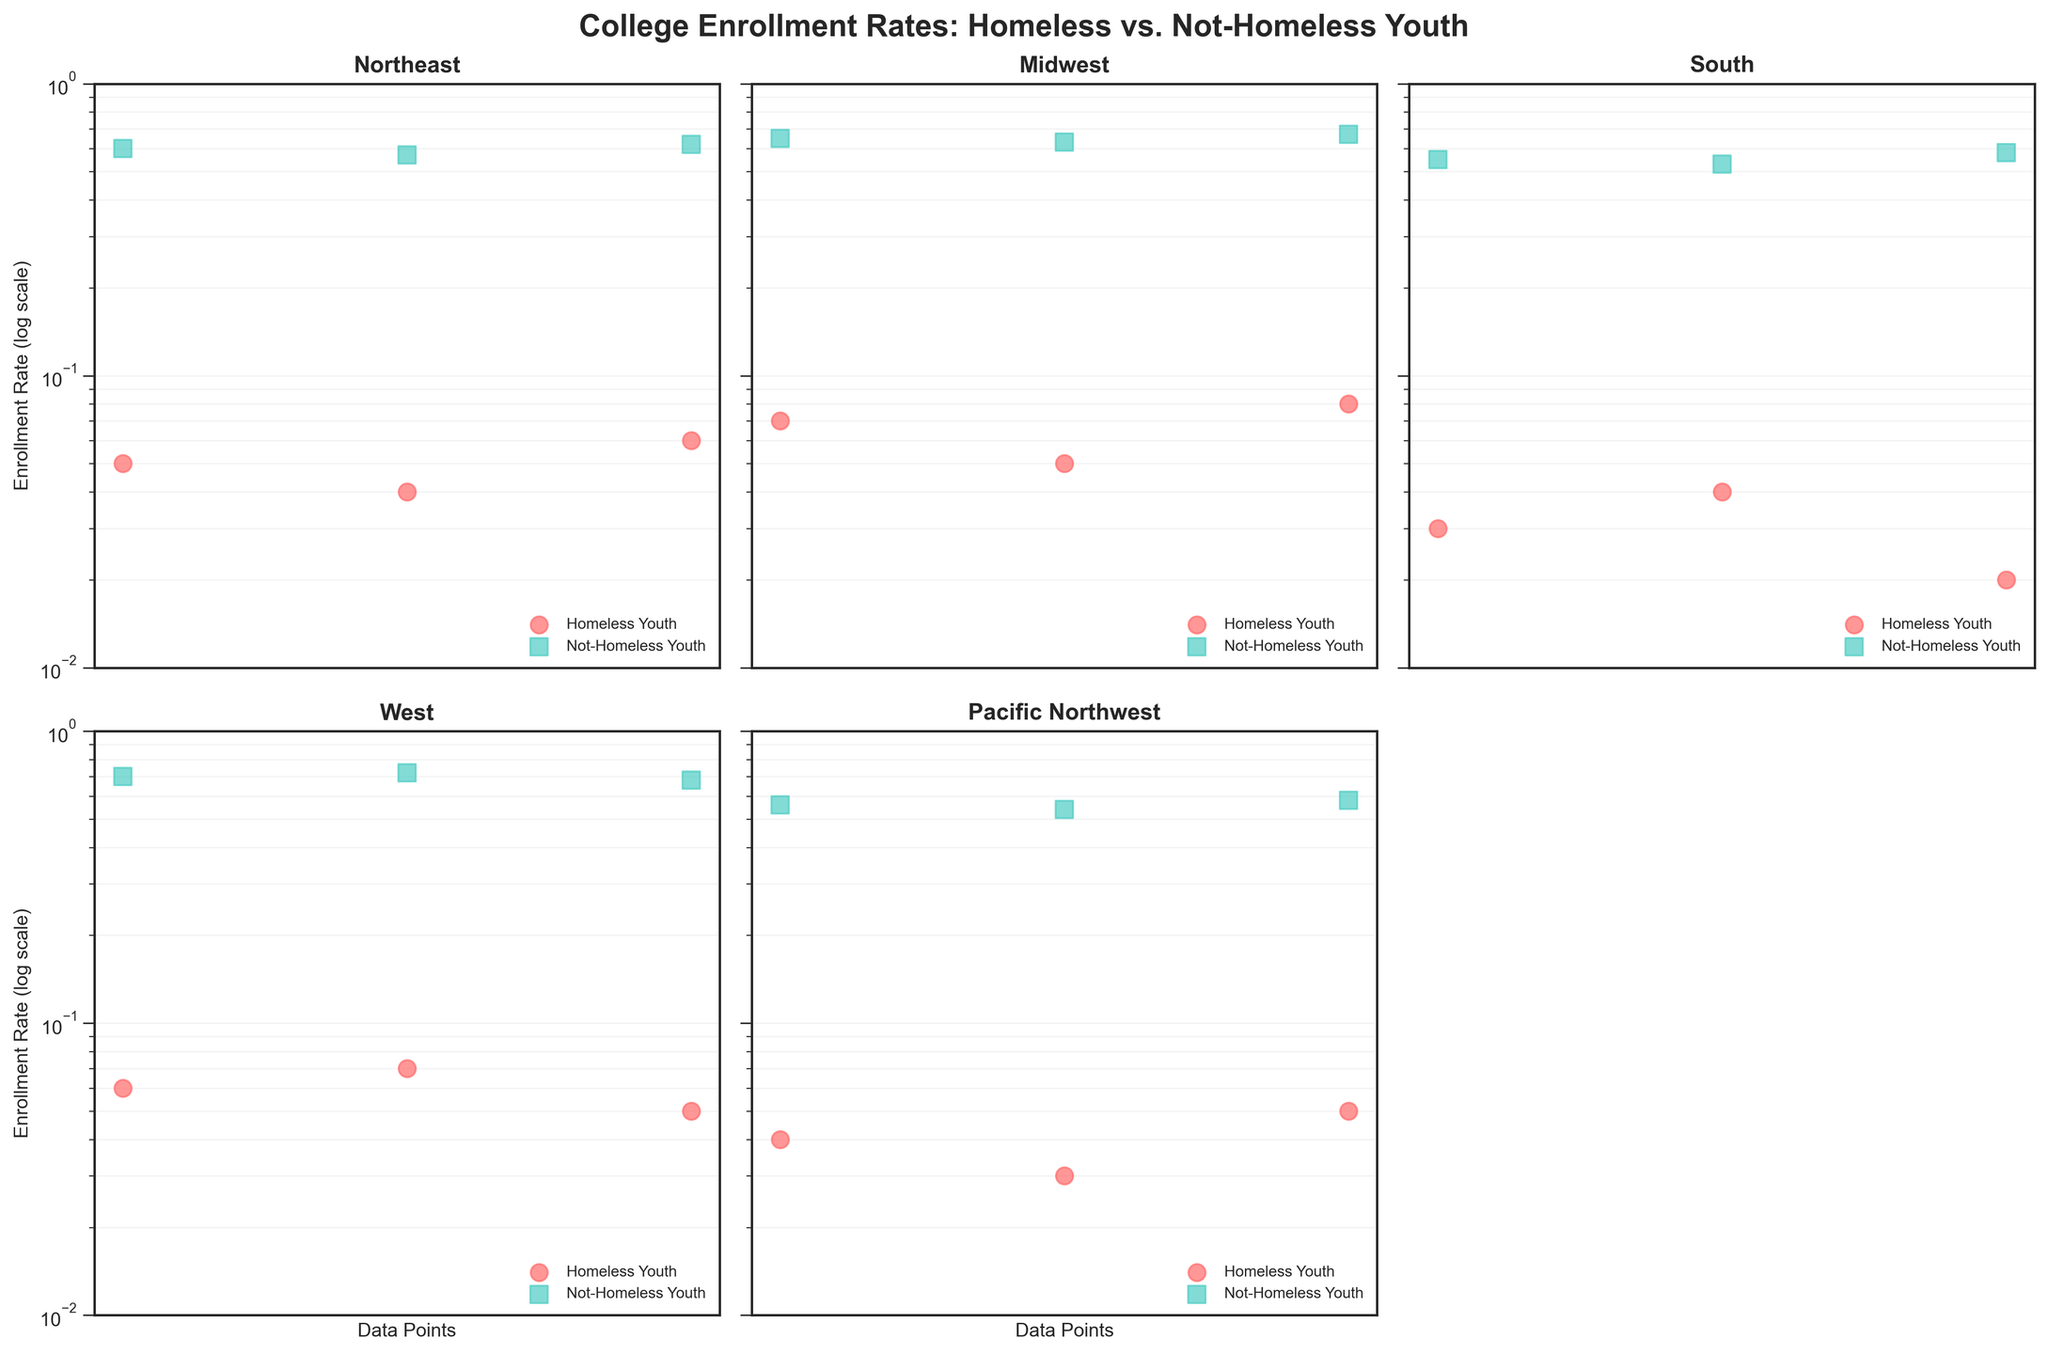what is the title of the figure? The title of the figure is shown at the top and reads "College Enrollment Rates: Homeless vs. Not-Homeless Youth"
Answer: College Enrollment Rates: Homeless vs. Not-Homeless Youth How many regions are compared in the figure? Each subplot represents a different region, and there are a total of 5 regions represented in subplots.
Answer: 5 What are the colors used to represent 'Homeless Youth' and 'Not-Homeless Youth'? 'Homeless Youth' are represented in red, and 'Not-Homeless Youth' are represented in teal.
Answer: 'Homeless Youth' (Red), 'Not-Homeless Youth' (Teal) Which region has the smallest spread in college enrollment rates between homeless and not-homeless youth? By comparing the vertical separation between the two colors in each subplot, the 'South' region has the smallest spread in college enrollment rates between homeless and not-homeless youth, showing the least difference.
Answer: South For the Midwest region, what is the highest enrollment rate for homeless youth? The highest point in the Midwest subplot, indicated by a red marker, represents the highest enrollment rate for homeless youth, which is 0.08 (8%).
Answer: 0.08 What is the general trend in college enrollment rates for homeless youth across all regions? By examining all subplots, it is clear that the college enrollment rates for homeless youth are generally much lower than those for not-homeless youth, with rates clustering around 0.02 to 0.08 (2% - 8%) on the vertical log scale axis.
Answer: Lower In the Northeast region, how much higher is the highest not-homeless youth enrollment rate compared to the highest homeless youth enrollment rate? The highest not-homeless youth enrollment rate in the Northeast region is 0.62 (62%), and the highest homeless youth enrollment rate is 0.06 (6%). The difference between these rates is 0.62 - 0.06 = 0.56 (56%).
Answer: 0.56 Considering the Pacific Northwest region, do homeless youth or not-homeless youth have a wider range of enrollment rates? In the Pacific Northwest subplot, the vertical spread of the teal markers (not-homeless youth) appears wider than the red markers (homeless youth), indicating a larger variability in enrollment rates for not-homeless youth.
Answer: Not-homeless youth Which region shows the highest college enrollment rate for not-homeless youth? The West region has the highest marked points at 0.70, 0.72, and 0.68 (70%, 72%, and 68%) for not-homeless youth.
Answer: West 